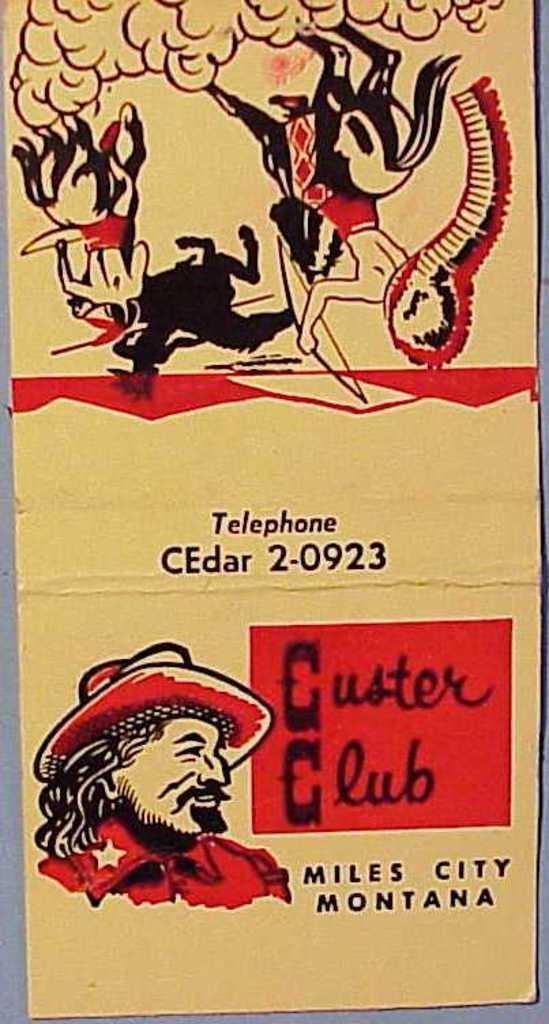How would you summarize this image in a sentence or two? In this image we can see a card on which several paintings and some text are present. 